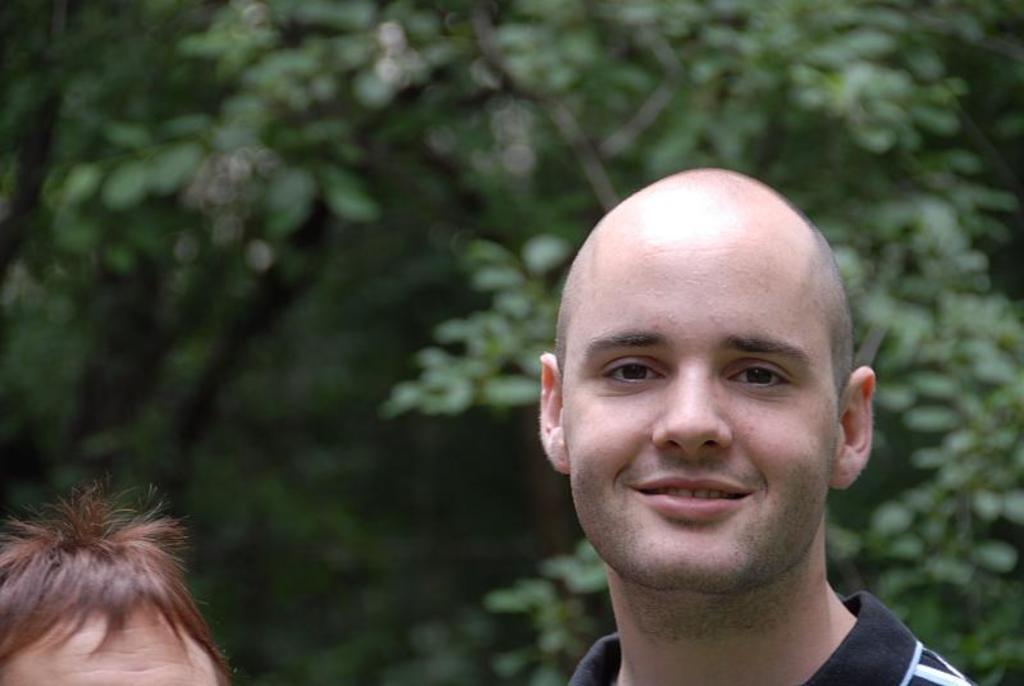Could you give a brief overview of what you see in this image? In this picture we can see two people and in the background we can see trees and it is blurry. 